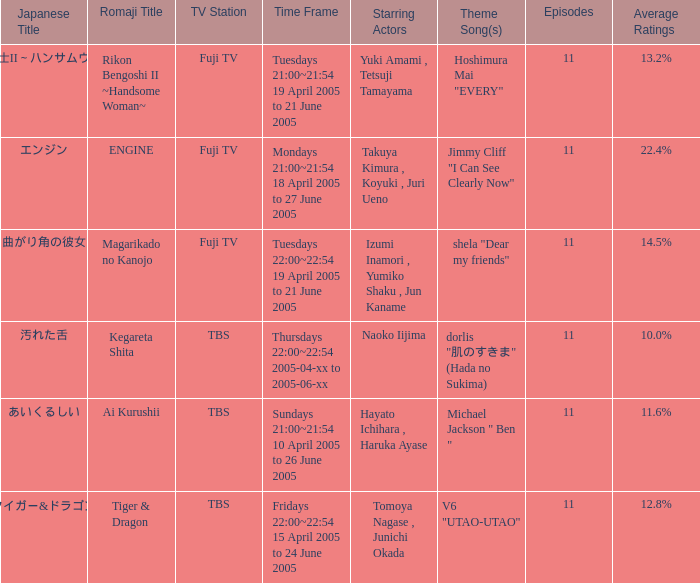Identify the japanese title that holds an average rating of 11.6%. あいくるしい. 